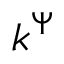<formula> <loc_0><loc_0><loc_500><loc_500>k ^ { \Psi }</formula> 